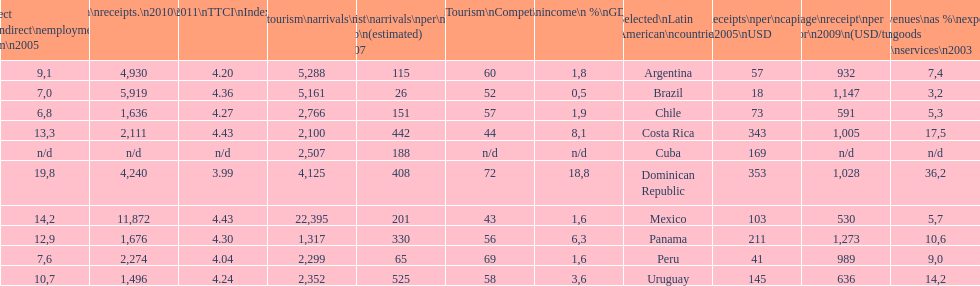What country makes the most tourist income? Dominican Republic. 